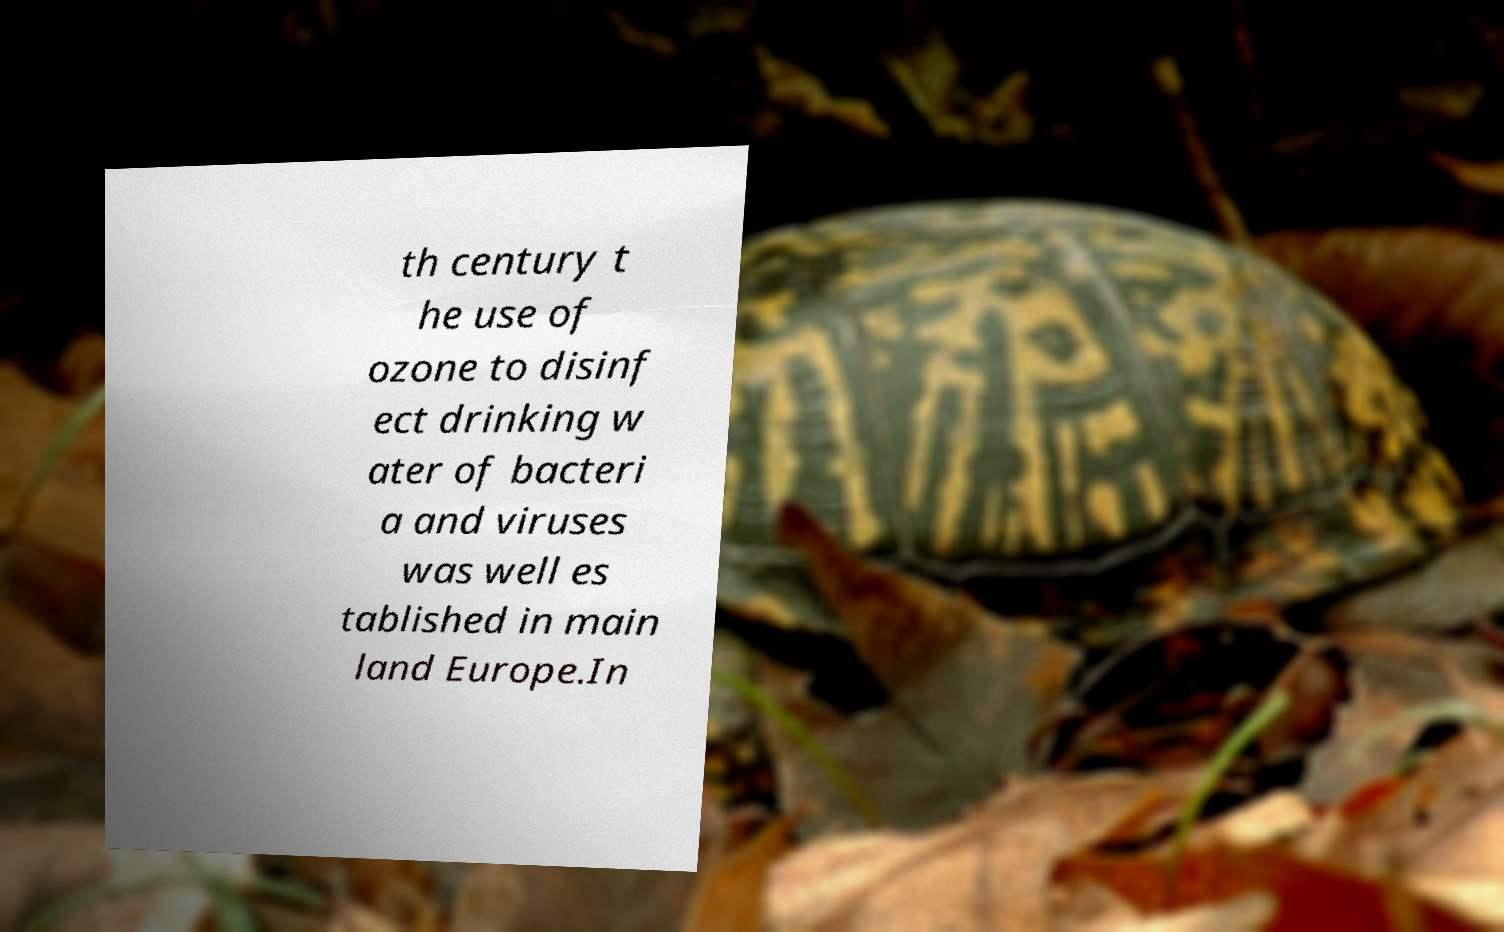I need the written content from this picture converted into text. Can you do that? th century t he use of ozone to disinf ect drinking w ater of bacteri a and viruses was well es tablished in main land Europe.In 